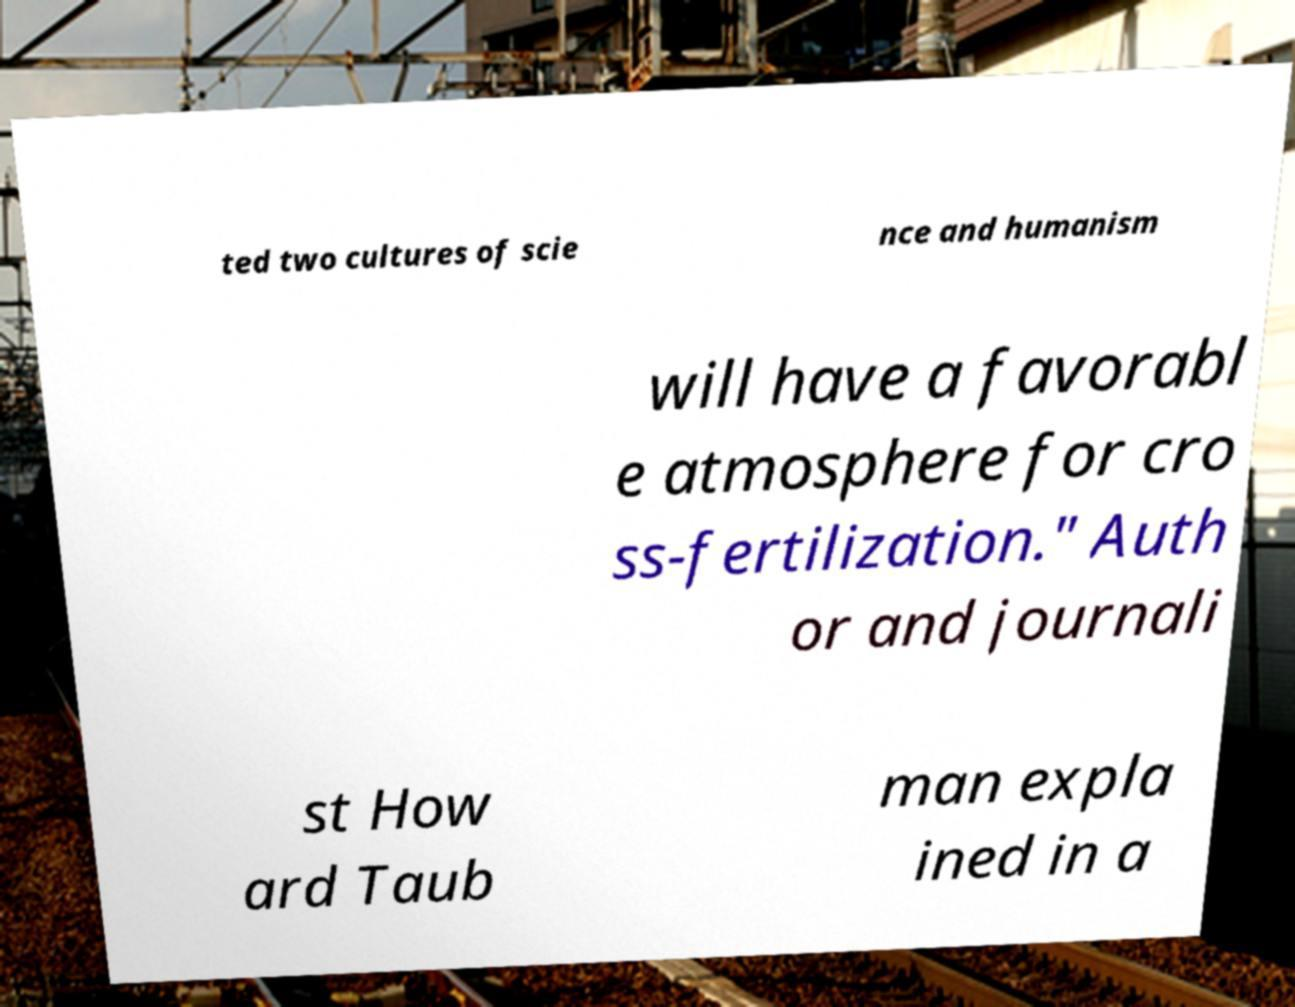I need the written content from this picture converted into text. Can you do that? ted two cultures of scie nce and humanism will have a favorabl e atmosphere for cro ss-fertilization." Auth or and journali st How ard Taub man expla ined in a 